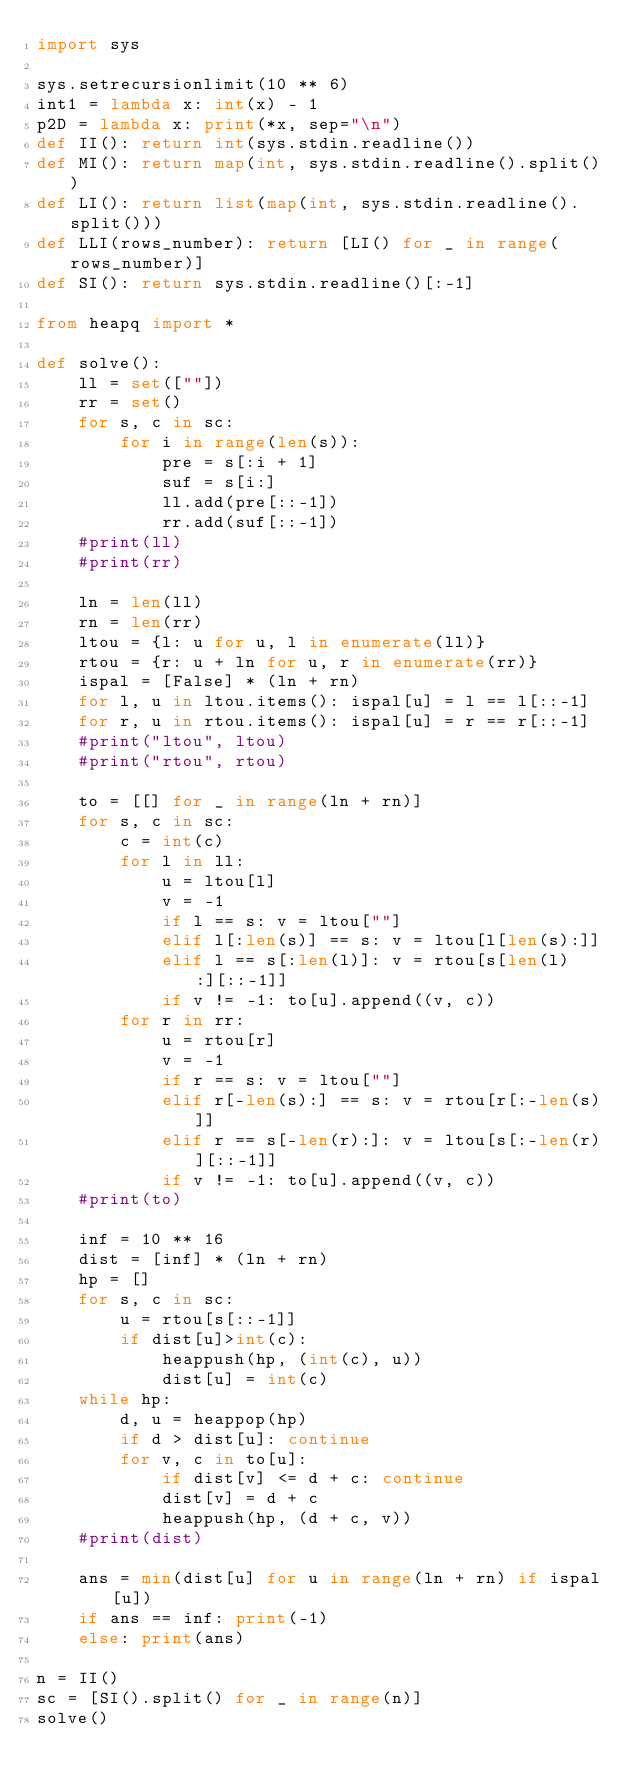<code> <loc_0><loc_0><loc_500><loc_500><_Python_>import sys

sys.setrecursionlimit(10 ** 6)
int1 = lambda x: int(x) - 1
p2D = lambda x: print(*x, sep="\n")
def II(): return int(sys.stdin.readline())
def MI(): return map(int, sys.stdin.readline().split())
def LI(): return list(map(int, sys.stdin.readline().split()))
def LLI(rows_number): return [LI() for _ in range(rows_number)]
def SI(): return sys.stdin.readline()[:-1]

from heapq import *

def solve():
    ll = set([""])
    rr = set()
    for s, c in sc:
        for i in range(len(s)):
            pre = s[:i + 1]
            suf = s[i:]
            ll.add(pre[::-1])
            rr.add(suf[::-1])
    #print(ll)
    #print(rr)

    ln = len(ll)
    rn = len(rr)
    ltou = {l: u for u, l in enumerate(ll)}
    rtou = {r: u + ln for u, r in enumerate(rr)}
    ispal = [False] * (ln + rn)
    for l, u in ltou.items(): ispal[u] = l == l[::-1]
    for r, u in rtou.items(): ispal[u] = r == r[::-1]
    #print("ltou", ltou)
    #print("rtou", rtou)

    to = [[] for _ in range(ln + rn)]
    for s, c in sc:
        c = int(c)
        for l in ll:
            u = ltou[l]
            v = -1
            if l == s: v = ltou[""]
            elif l[:len(s)] == s: v = ltou[l[len(s):]]
            elif l == s[:len(l)]: v = rtou[s[len(l):][::-1]]
            if v != -1: to[u].append((v, c))
        for r in rr:
            u = rtou[r]
            v = -1
            if r == s: v = ltou[""]
            elif r[-len(s):] == s: v = rtou[r[:-len(s)]]
            elif r == s[-len(r):]: v = ltou[s[:-len(r)][::-1]]
            if v != -1: to[u].append((v, c))
    #print(to)

    inf = 10 ** 16
    dist = [inf] * (ln + rn)
    hp = []
    for s, c in sc:
        u = rtou[s[::-1]]
        if dist[u]>int(c):
            heappush(hp, (int(c), u))
            dist[u] = int(c)
    while hp:
        d, u = heappop(hp)
        if d > dist[u]: continue
        for v, c in to[u]:
            if dist[v] <= d + c: continue
            dist[v] = d + c
            heappush(hp, (d + c, v))
    #print(dist)

    ans = min(dist[u] for u in range(ln + rn) if ispal[u])
    if ans == inf: print(-1)
    else: print(ans)

n = II()
sc = [SI().split() for _ in range(n)]
solve()
</code> 